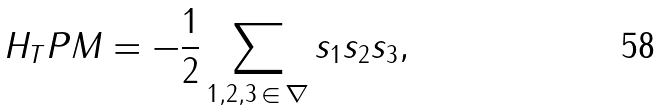Convert formula to latex. <formula><loc_0><loc_0><loc_500><loc_500>H _ { T } P M = - \frac { 1 } { 2 } \sum _ { 1 , 2 , 3 \, \in \, \nabla } s _ { 1 } s _ { 2 } s _ { 3 } ,</formula> 